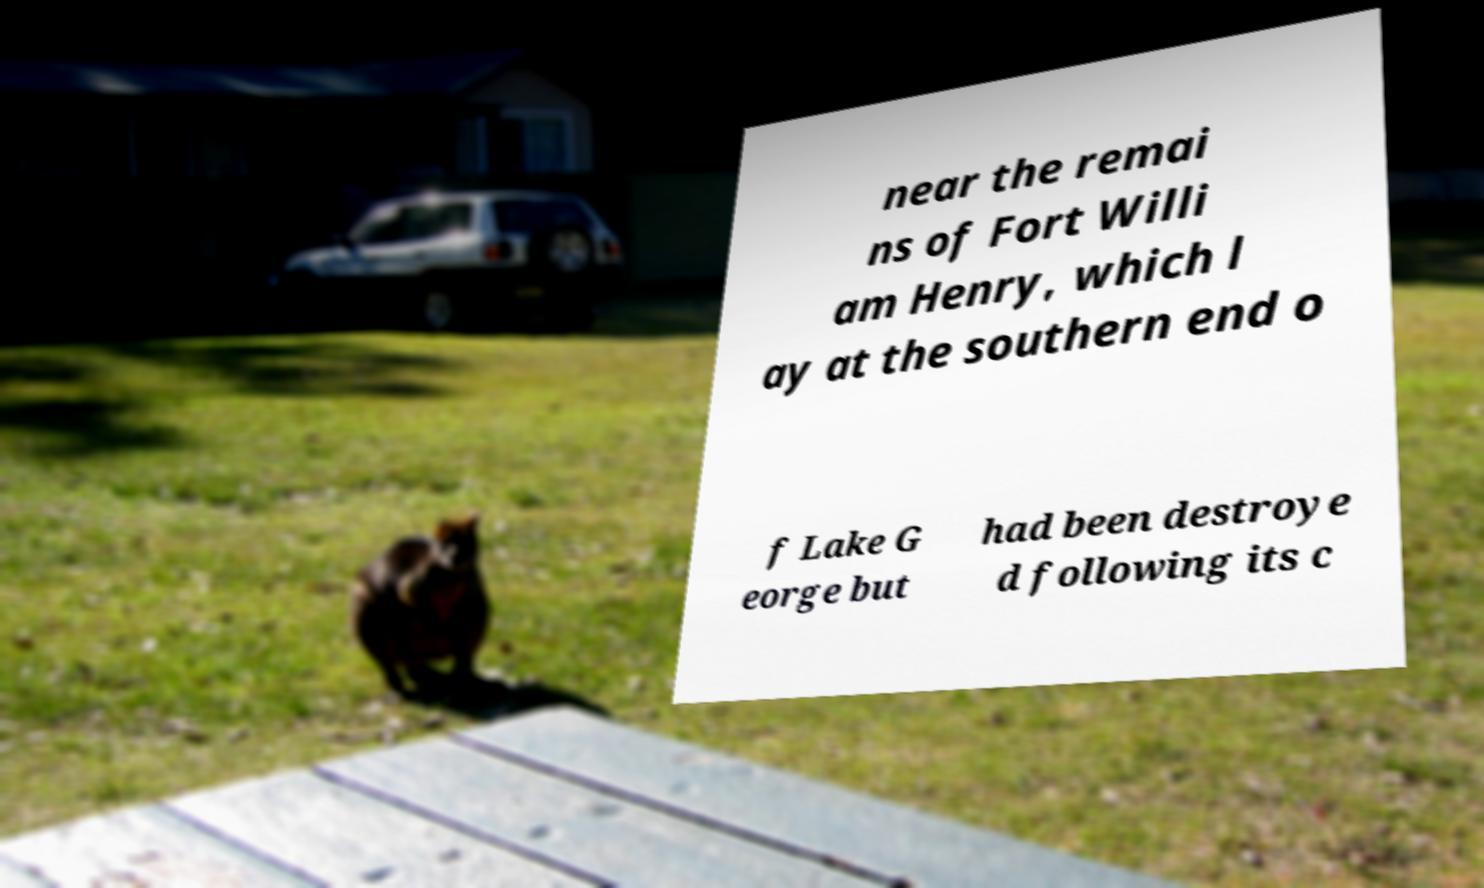Please read and relay the text visible in this image. What does it say? near the remai ns of Fort Willi am Henry, which l ay at the southern end o f Lake G eorge but had been destroye d following its c 